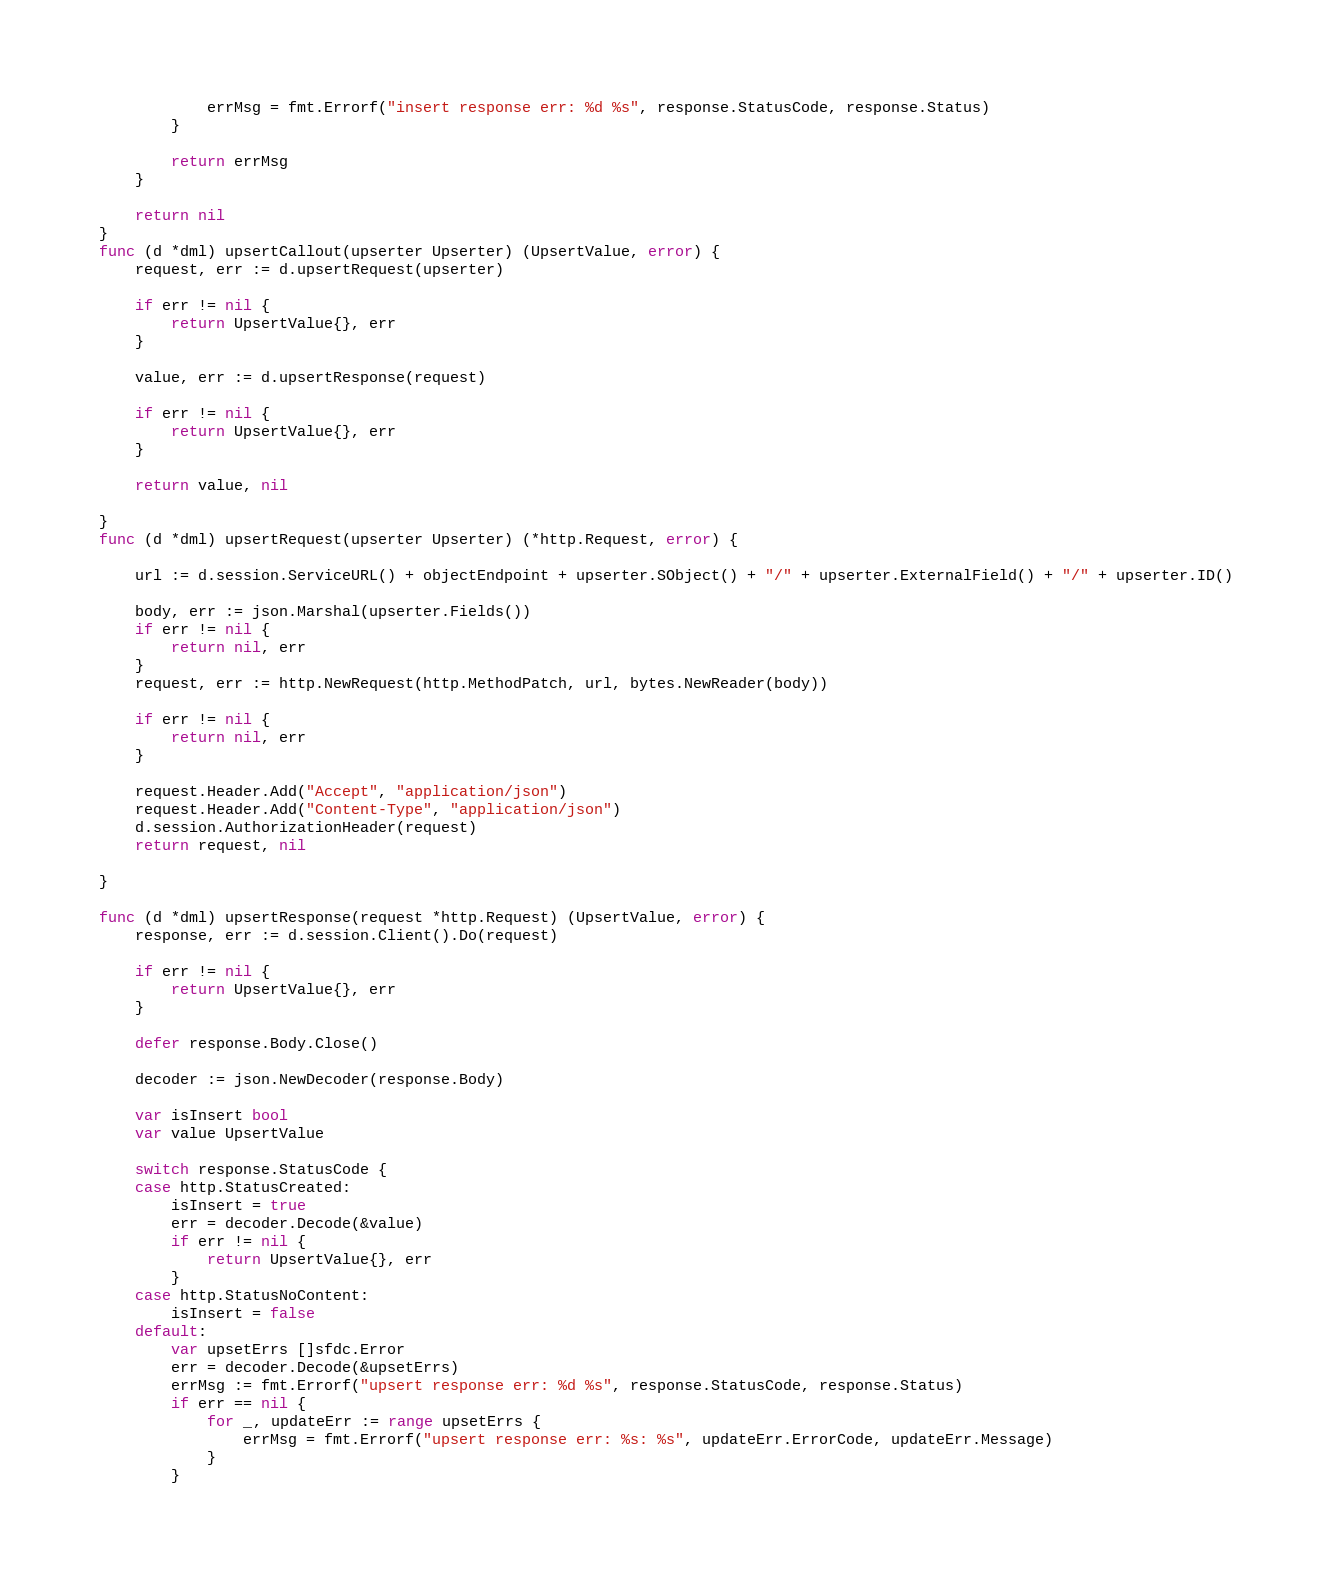<code> <loc_0><loc_0><loc_500><loc_500><_Go_>			errMsg = fmt.Errorf("insert response err: %d %s", response.StatusCode, response.Status)
		}

		return errMsg
	}

	return nil
}
func (d *dml) upsertCallout(upserter Upserter) (UpsertValue, error) {
	request, err := d.upsertRequest(upserter)

	if err != nil {
		return UpsertValue{}, err
	}

	value, err := d.upsertResponse(request)

	if err != nil {
		return UpsertValue{}, err
	}

	return value, nil

}
func (d *dml) upsertRequest(upserter Upserter) (*http.Request, error) {

	url := d.session.ServiceURL() + objectEndpoint + upserter.SObject() + "/" + upserter.ExternalField() + "/" + upserter.ID()

	body, err := json.Marshal(upserter.Fields())
	if err != nil {
		return nil, err
	}
	request, err := http.NewRequest(http.MethodPatch, url, bytes.NewReader(body))

	if err != nil {
		return nil, err
	}

	request.Header.Add("Accept", "application/json")
	request.Header.Add("Content-Type", "application/json")
	d.session.AuthorizationHeader(request)
	return request, nil

}

func (d *dml) upsertResponse(request *http.Request) (UpsertValue, error) {
	response, err := d.session.Client().Do(request)

	if err != nil {
		return UpsertValue{}, err
	}

	defer response.Body.Close()

	decoder := json.NewDecoder(response.Body)

	var isInsert bool
	var value UpsertValue

	switch response.StatusCode {
	case http.StatusCreated:
		isInsert = true
		err = decoder.Decode(&value)
		if err != nil {
			return UpsertValue{}, err
		}
	case http.StatusNoContent:
		isInsert = false
	default:
		var upsetErrs []sfdc.Error
		err = decoder.Decode(&upsetErrs)
		errMsg := fmt.Errorf("upsert response err: %d %s", response.StatusCode, response.Status)
		if err == nil {
			for _, updateErr := range upsetErrs {
				errMsg = fmt.Errorf("upsert response err: %s: %s", updateErr.ErrorCode, updateErr.Message)
			}
		}</code> 